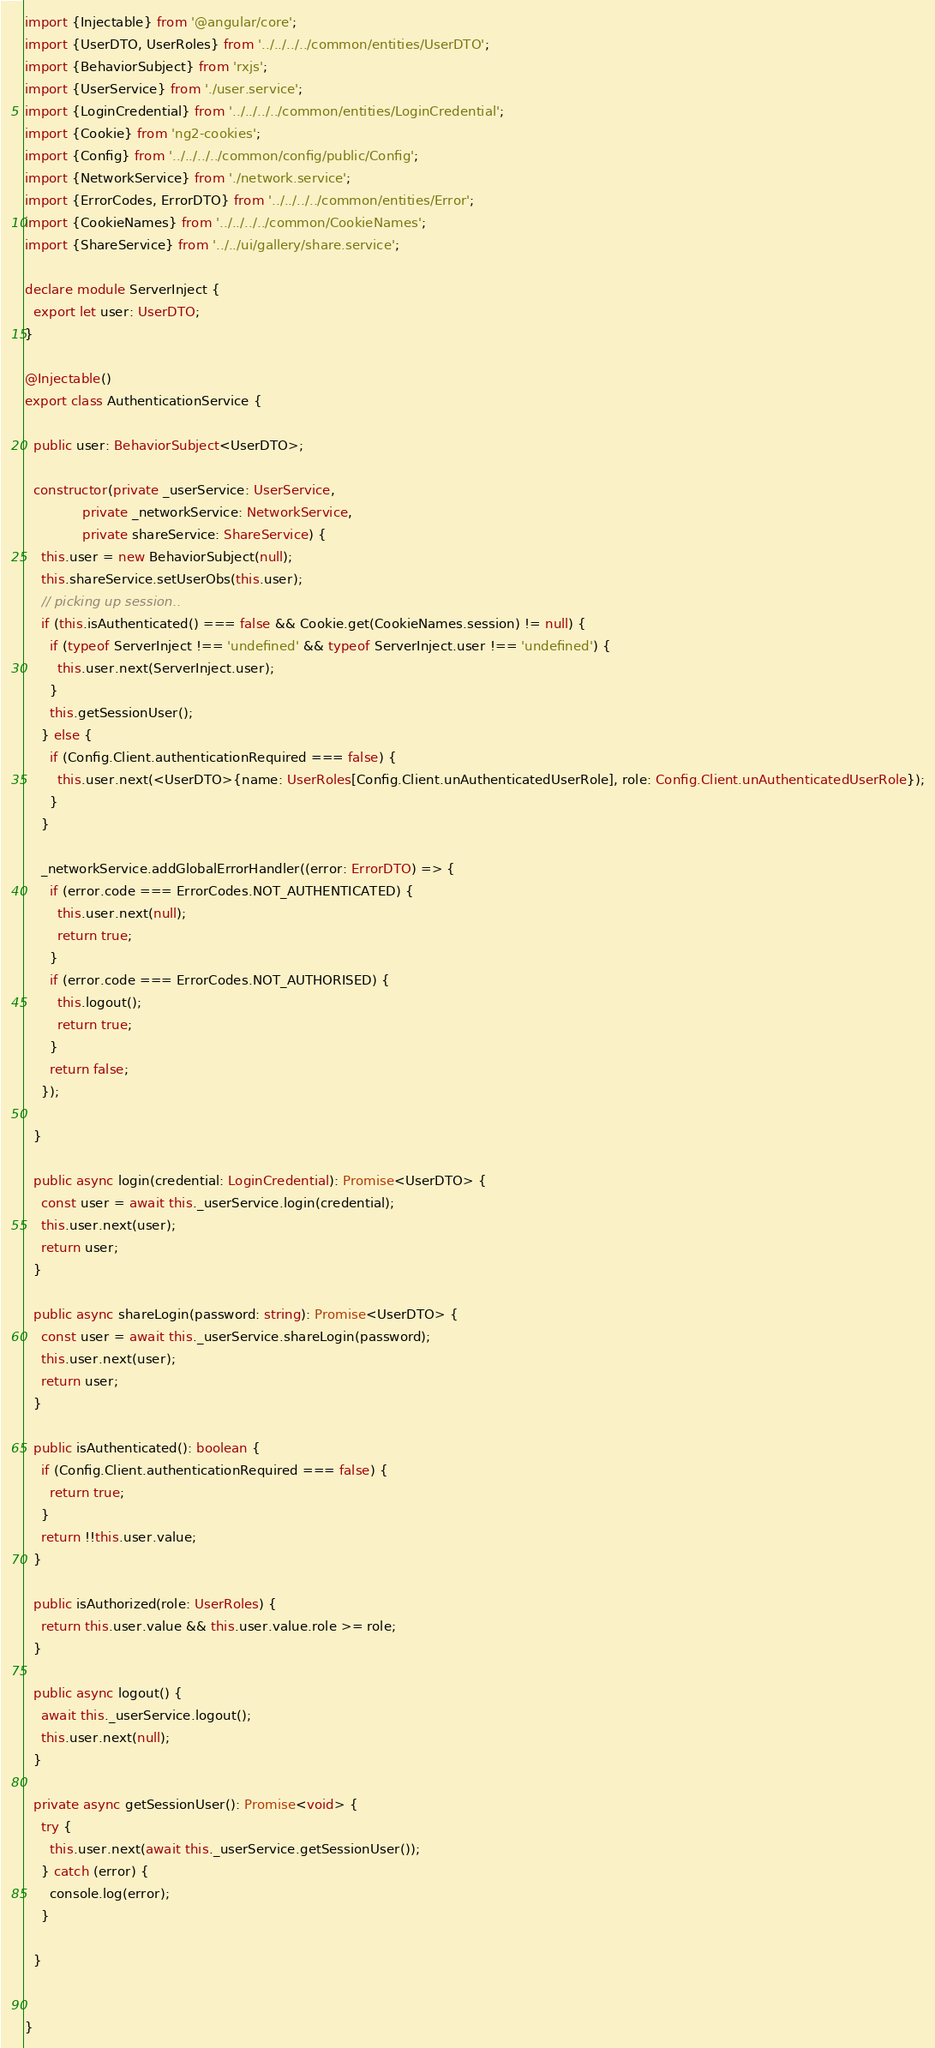Convert code to text. <code><loc_0><loc_0><loc_500><loc_500><_TypeScript_>import {Injectable} from '@angular/core';
import {UserDTO, UserRoles} from '../../../../common/entities/UserDTO';
import {BehaviorSubject} from 'rxjs';
import {UserService} from './user.service';
import {LoginCredential} from '../../../../common/entities/LoginCredential';
import {Cookie} from 'ng2-cookies';
import {Config} from '../../../../common/config/public/Config';
import {NetworkService} from './network.service';
import {ErrorCodes, ErrorDTO} from '../../../../common/entities/Error';
import {CookieNames} from '../../../../common/CookieNames';
import {ShareService} from '../../ui/gallery/share.service';

declare module ServerInject {
  export let user: UserDTO;
}

@Injectable()
export class AuthenticationService {

  public user: BehaviorSubject<UserDTO>;

  constructor(private _userService: UserService,
              private _networkService: NetworkService,
              private shareService: ShareService) {
    this.user = new BehaviorSubject(null);
    this.shareService.setUserObs(this.user);
    // picking up session..
    if (this.isAuthenticated() === false && Cookie.get(CookieNames.session) != null) {
      if (typeof ServerInject !== 'undefined' && typeof ServerInject.user !== 'undefined') {
        this.user.next(ServerInject.user);
      }
      this.getSessionUser();
    } else {
      if (Config.Client.authenticationRequired === false) {
        this.user.next(<UserDTO>{name: UserRoles[Config.Client.unAuthenticatedUserRole], role: Config.Client.unAuthenticatedUserRole});
      }
    }

    _networkService.addGlobalErrorHandler((error: ErrorDTO) => {
      if (error.code === ErrorCodes.NOT_AUTHENTICATED) {
        this.user.next(null);
        return true;
      }
      if (error.code === ErrorCodes.NOT_AUTHORISED) {
        this.logout();
        return true;
      }
      return false;
    });

  }

  public async login(credential: LoginCredential): Promise<UserDTO> {
    const user = await this._userService.login(credential);
    this.user.next(user);
    return user;
  }

  public async shareLogin(password: string): Promise<UserDTO> {
    const user = await this._userService.shareLogin(password);
    this.user.next(user);
    return user;
  }

  public isAuthenticated(): boolean {
    if (Config.Client.authenticationRequired === false) {
      return true;
    }
    return !!this.user.value;
  }

  public isAuthorized(role: UserRoles) {
    return this.user.value && this.user.value.role >= role;
  }

  public async logout() {
    await this._userService.logout();
    this.user.next(null);
  }

  private async getSessionUser(): Promise<void> {
    try {
      this.user.next(await this._userService.getSessionUser());
    } catch (error) {
      console.log(error);
    }

  }


}
</code> 